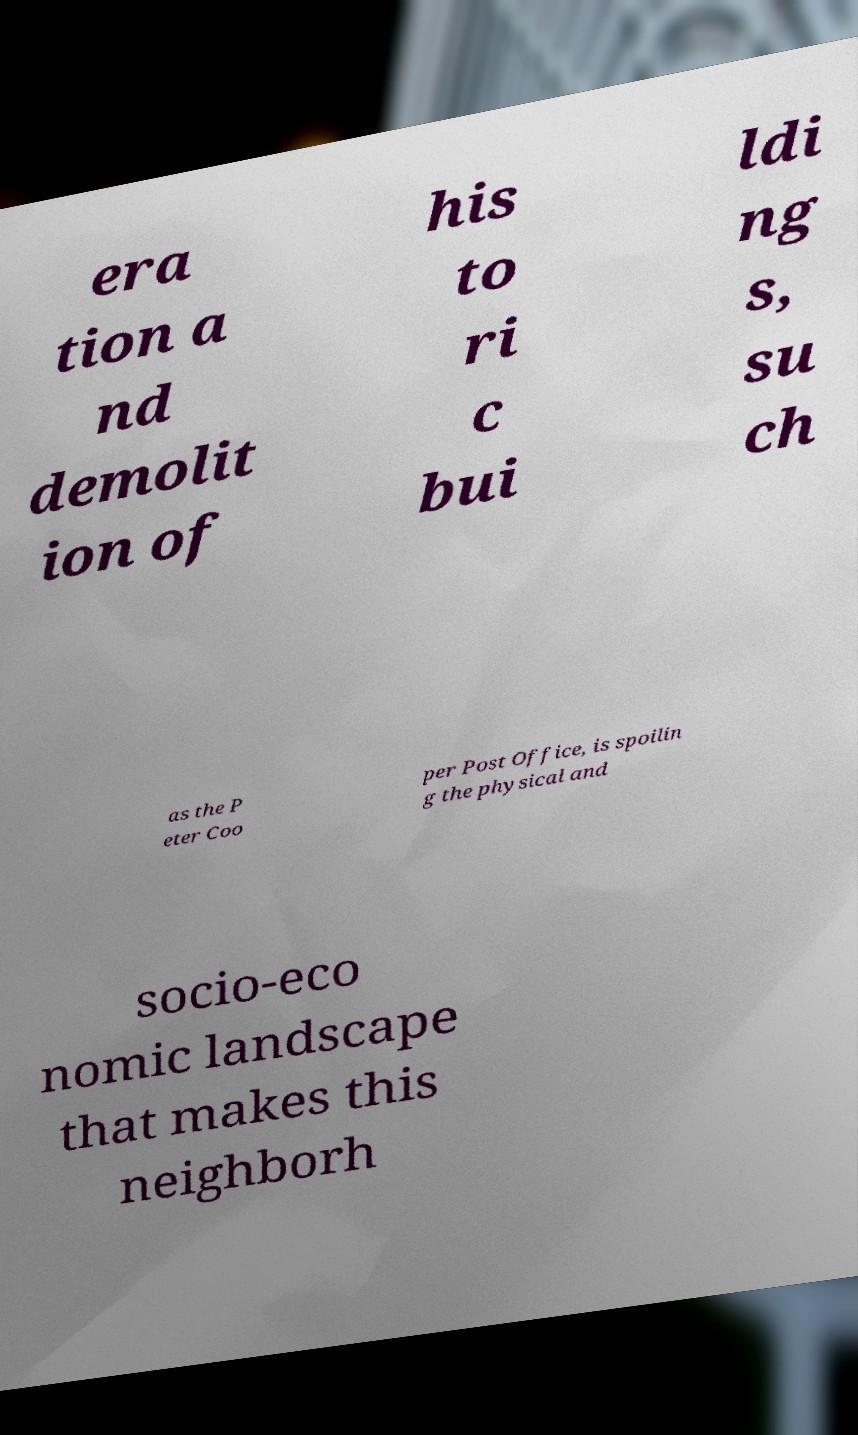Please identify and transcribe the text found in this image. era tion a nd demolit ion of his to ri c bui ldi ng s, su ch as the P eter Coo per Post Office, is spoilin g the physical and socio-eco nomic landscape that makes this neighborh 